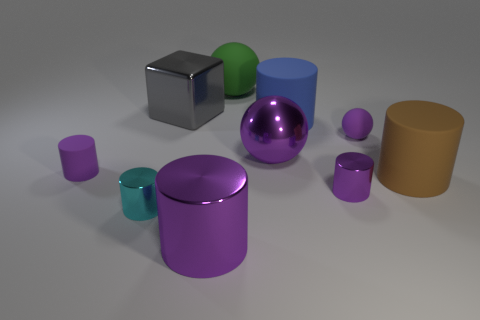What is the material of the block?
Give a very brief answer. Metal. What is the purple cylinder in front of the small cyan metal cylinder made of?
Your answer should be compact. Metal. Is the number of big purple shiny spheres that are behind the large brown matte cylinder greater than the number of large red things?
Provide a short and direct response. Yes. Is there a big rubber cylinder in front of the small purple object on the left side of the metal cylinder on the right side of the large purple metallic cylinder?
Your answer should be very brief. Yes. Are there any large matte balls in front of the small cyan metallic object?
Your response must be concise. No. How many cubes have the same color as the small matte ball?
Give a very brief answer. 0. What size is the brown cylinder that is made of the same material as the green ball?
Offer a very short reply. Large. There is a rubber ball that is in front of the ball behind the cylinder behind the small purple rubber sphere; what size is it?
Provide a succinct answer. Small. What is the size of the matte ball in front of the blue rubber cylinder?
Ensure brevity in your answer.  Small. What number of cyan things are large objects or metal balls?
Make the answer very short. 0. 